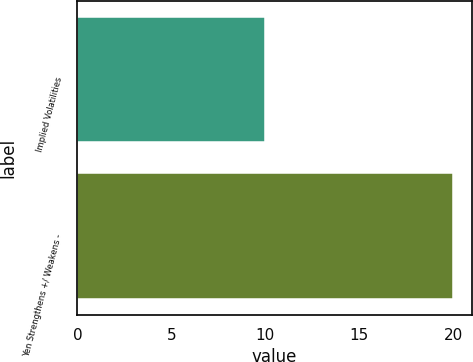Convert chart. <chart><loc_0><loc_0><loc_500><loc_500><bar_chart><fcel>Implied Volatilities<fcel>Yen Strengthens +/ Weakens -<nl><fcel>10<fcel>20<nl></chart> 